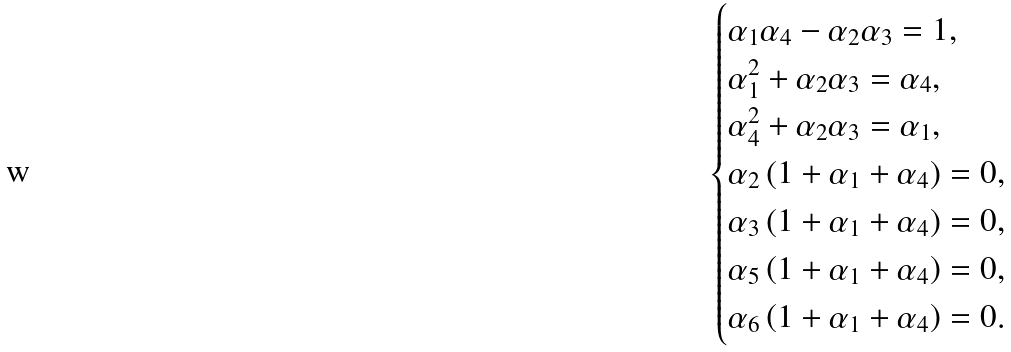Convert formula to latex. <formula><loc_0><loc_0><loc_500><loc_500>\begin{cases} \alpha _ { 1 } \alpha _ { 4 } - \alpha _ { 2 } \alpha _ { 3 } = 1 , \\ \alpha _ { 1 } ^ { 2 } + \alpha _ { 2 } \alpha _ { 3 } = \alpha _ { 4 } , \\ \alpha _ { 4 } ^ { 2 } + \alpha _ { 2 } \alpha _ { 3 } = \alpha _ { 1 } , \\ \alpha _ { 2 } \left ( 1 + \alpha _ { 1 } + \alpha _ { 4 } \right ) = 0 , \\ \alpha _ { 3 } \left ( 1 + \alpha _ { 1 } + \alpha _ { 4 } \right ) = 0 , \\ \alpha _ { 5 } \left ( 1 + \alpha _ { 1 } + \alpha _ { 4 } \right ) = 0 , \\ \alpha _ { 6 } \left ( 1 + \alpha _ { 1 } + \alpha _ { 4 } \right ) = 0 . \end{cases}</formula> 